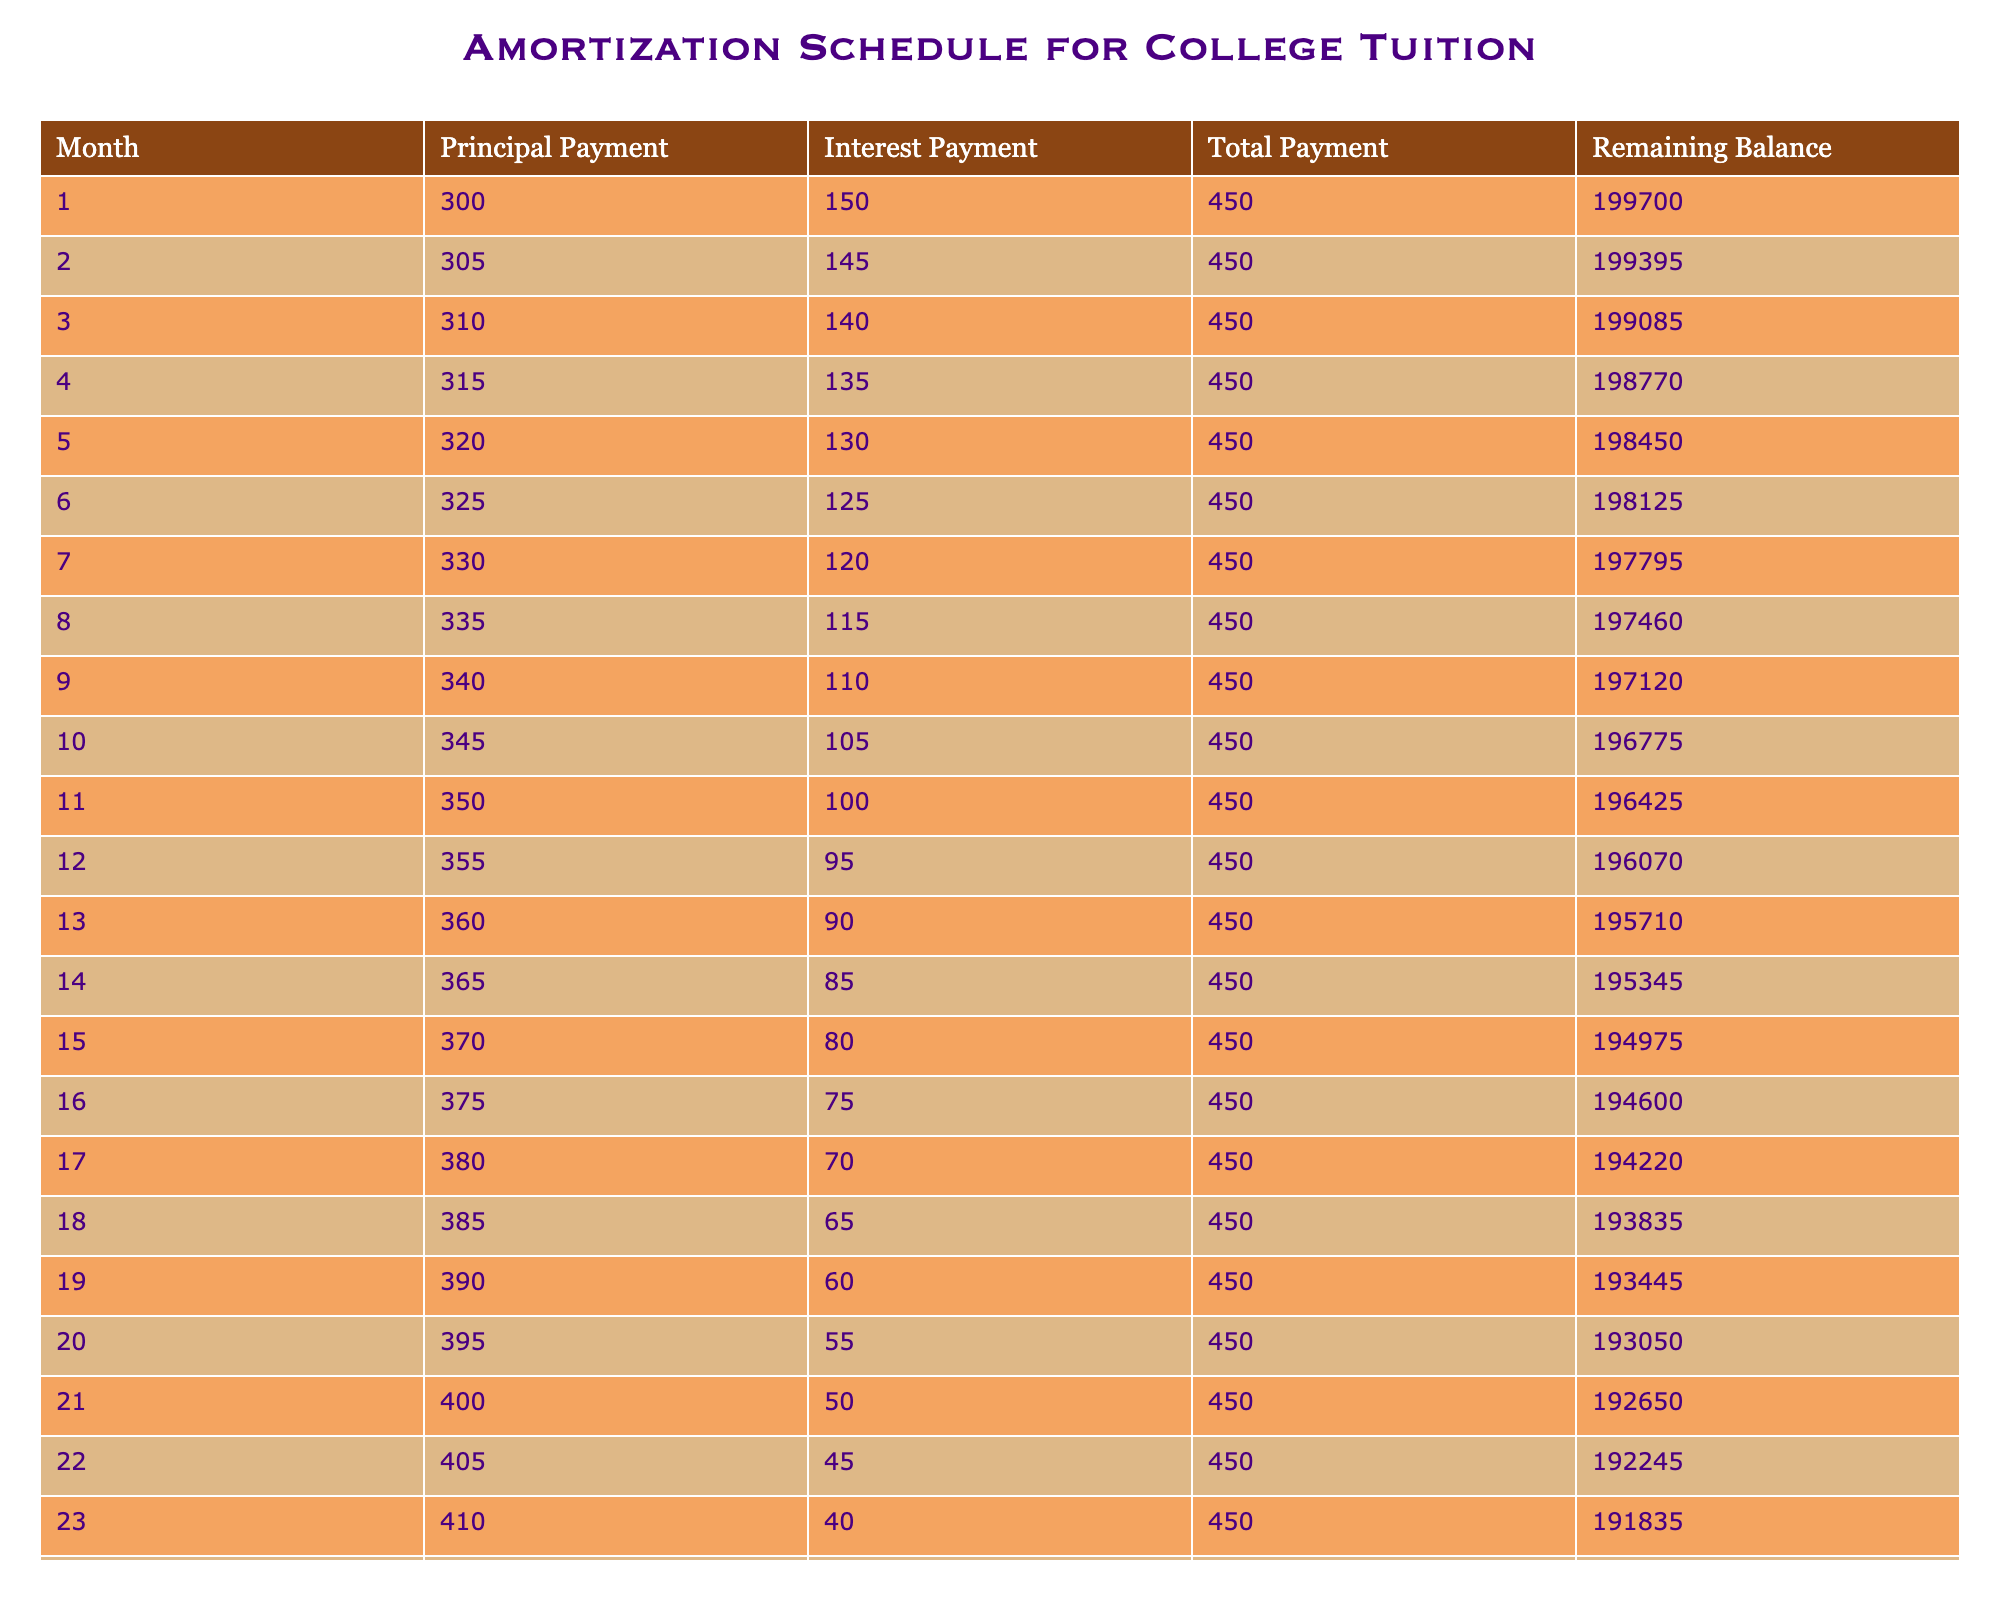What is the principal payment in the first month? According to the table, the principal payment listed for the first month is 300.
Answer: 300 What is the total payment made in the fifth month? The total payment for the fifth month is directly provided in the table as 450.
Answer: 450 How much interest was paid in the tenth month? The interest payment for the tenth month can be found in the table, which states it is 105.
Answer: 105 What is the remaining balance after the twentieth payment? In the table, the remaining balance after the twentieth payment is noted as 193050.
Answer: 193050 What is the average principal payment over the first four months? To find the average principal payment, first add the principal payments for the first four months: (300 + 305 + 310 + 315) = 1230. Since there are 4 months, divide by 4 to get the average: 1230/4 = 307.5.
Answer: 307.5 Is the interest payment in the first month greater than the interest payment in the last month? The interest payment in the first month is 150, while in the last month it is 35. Since 150 is greater than 35, the answer is yes.
Answer: Yes What is the difference in the total payments between the first and second months? The total payment in the first month is 450 and in the second month is also 450. Therefore, the difference is 450 - 450 = 0.
Answer: 0 How much total principal has been paid off after six months? The total principal paid off after six months can be calculated by adding the principal payments for the first six months: (300 + 305 + 310 + 315 + 320 + 325) = 1875.
Answer: 1875 What was the principal payment in the last month? The table shows that the principal payment in the last month, which is the twenty-fourth month, is 415.
Answer: 415 